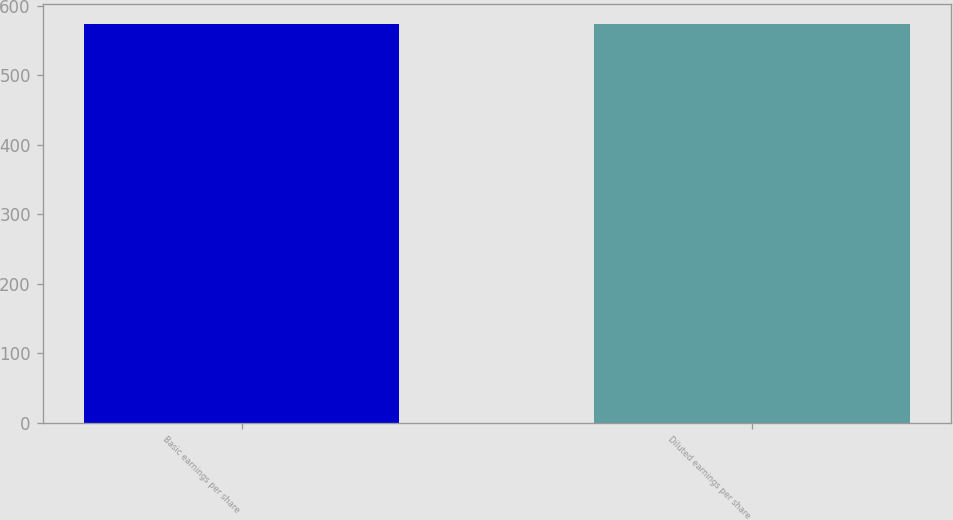Convert chart to OTSL. <chart><loc_0><loc_0><loc_500><loc_500><bar_chart><fcel>Basic earnings per share<fcel>Diluted earnings per share<nl><fcel>573.8<fcel>573.9<nl></chart> 